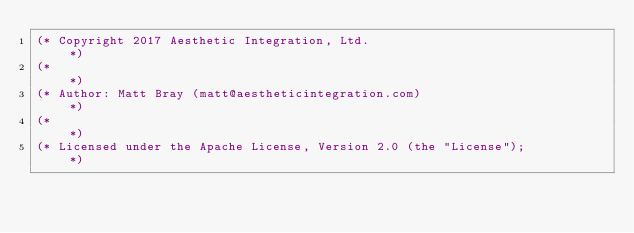Convert code to text. <code><loc_0><loc_0><loc_500><loc_500><_OCaml_>(* Copyright 2017 Aesthetic Integration, Ltd.                               *)
(*                                                                          *)
(* Author: Matt Bray (matt@aestheticintegration.com)                        *)
(*                                                                          *)
(* Licensed under the Apache License, Version 2.0 (the "License");          *)</code> 